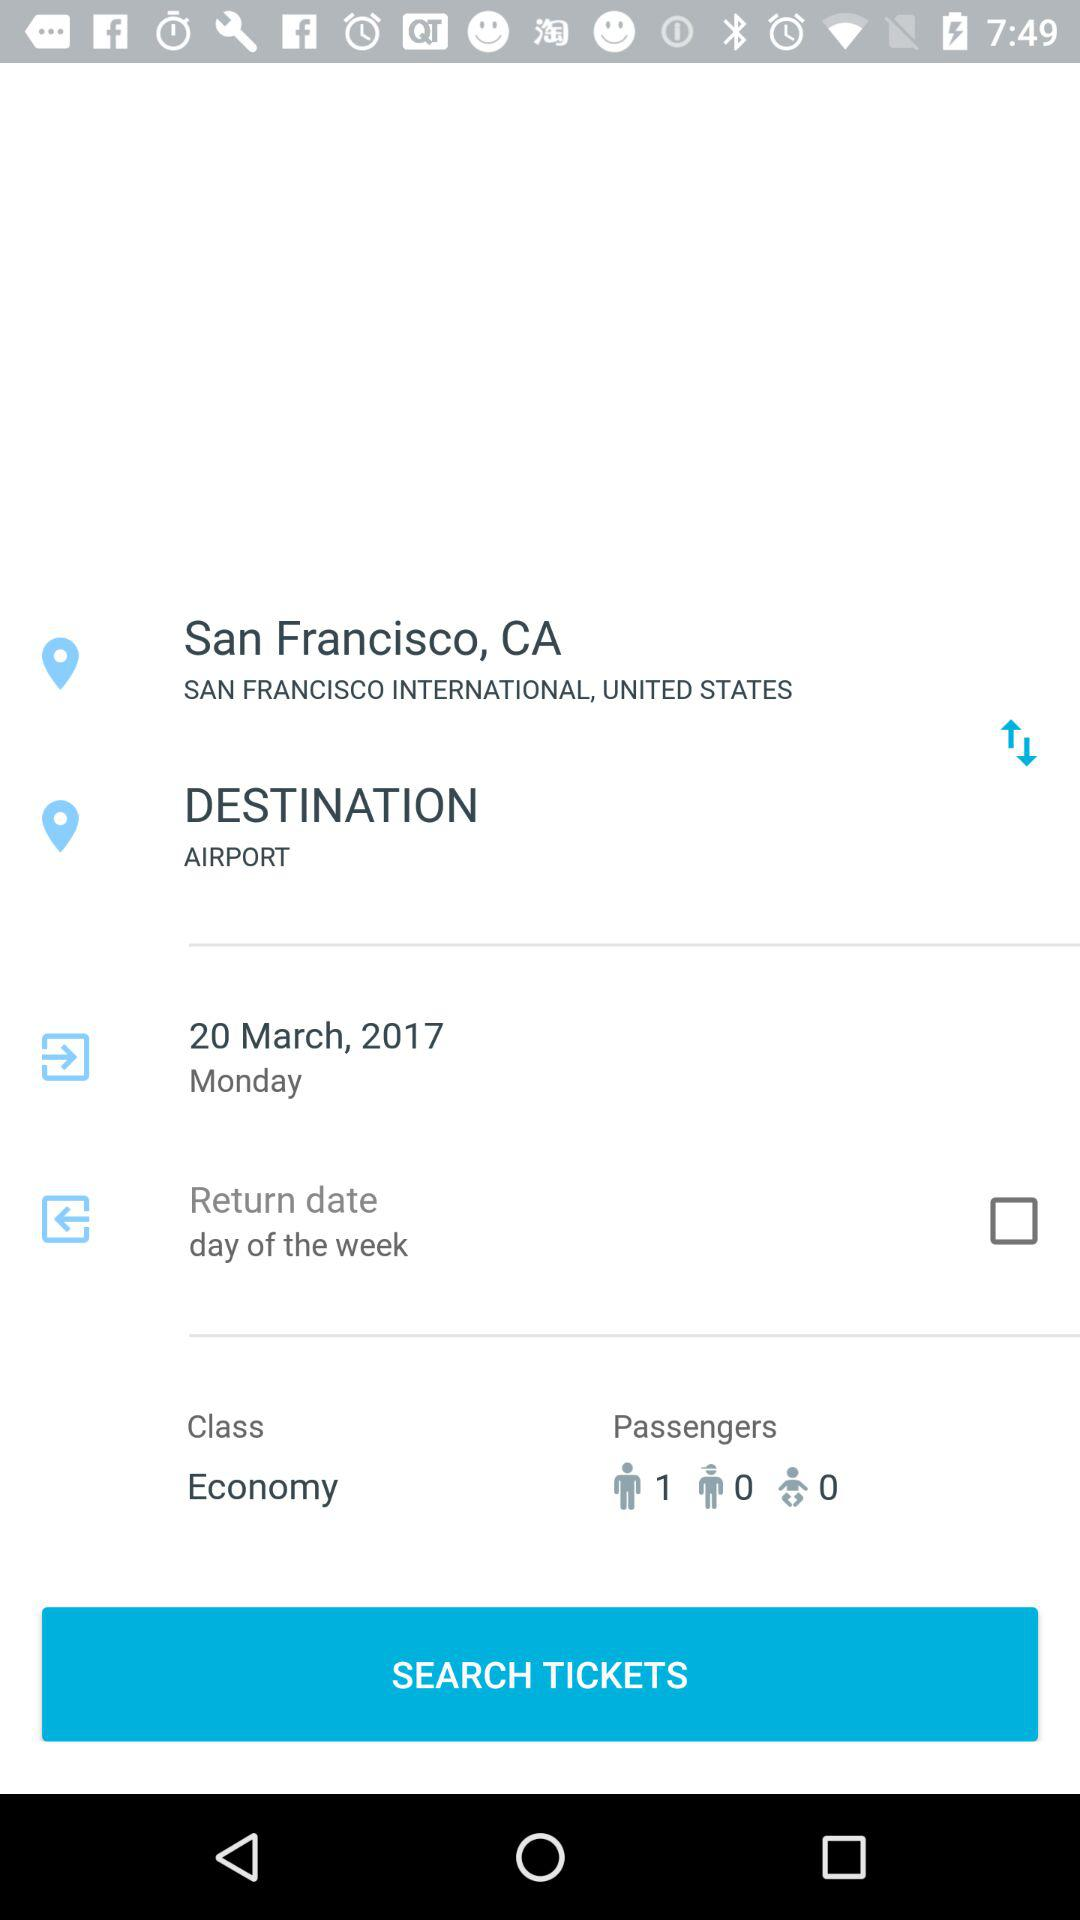How many passengers are flying?
Answer the question using a single word or phrase. 1 